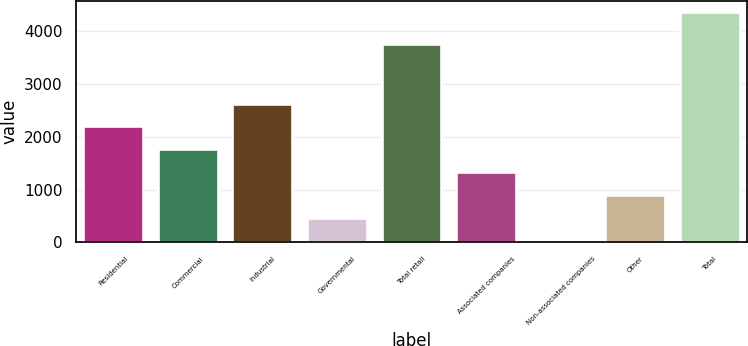Convert chart to OTSL. <chart><loc_0><loc_0><loc_500><loc_500><bar_chart><fcel>Residential<fcel>Commercial<fcel>Industrial<fcel>Governmental<fcel>Total retail<fcel>Associated companies<fcel>Non-associated companies<fcel>Other<fcel>Total<nl><fcel>2199<fcel>1766.4<fcel>2631.6<fcel>468.6<fcel>3768<fcel>1333.8<fcel>36<fcel>901.2<fcel>4362<nl></chart> 